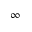<formula> <loc_0><loc_0><loc_500><loc_500>\infty</formula> 